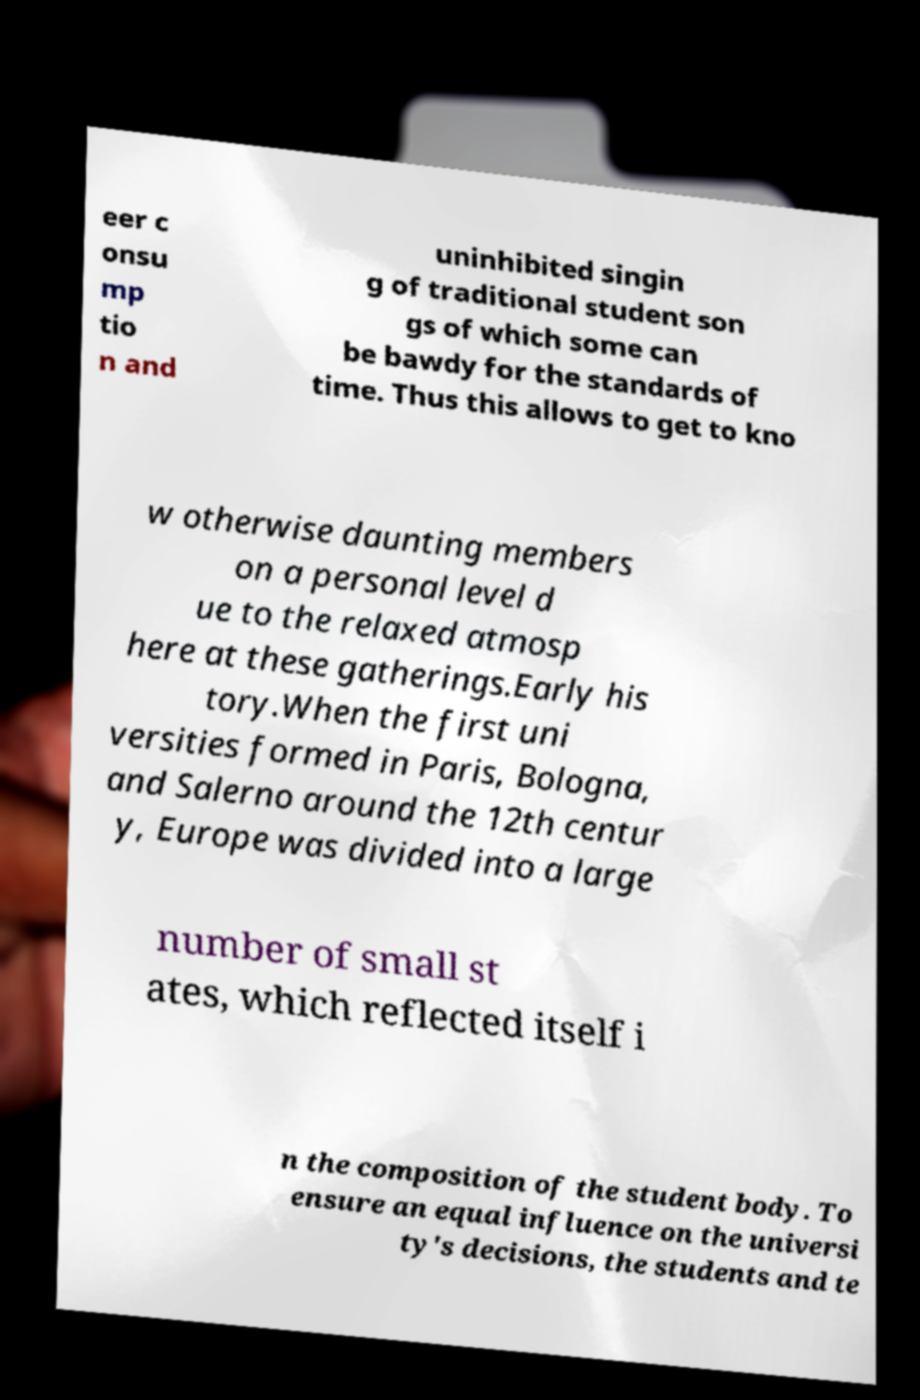Can you read and provide the text displayed in the image?This photo seems to have some interesting text. Can you extract and type it out for me? eer c onsu mp tio n and uninhibited singin g of traditional student son gs of which some can be bawdy for the standards of time. Thus this allows to get to kno w otherwise daunting members on a personal level d ue to the relaxed atmosp here at these gatherings.Early his tory.When the first uni versities formed in Paris, Bologna, and Salerno around the 12th centur y, Europe was divided into a large number of small st ates, which reflected itself i n the composition of the student body. To ensure an equal influence on the universi ty's decisions, the students and te 